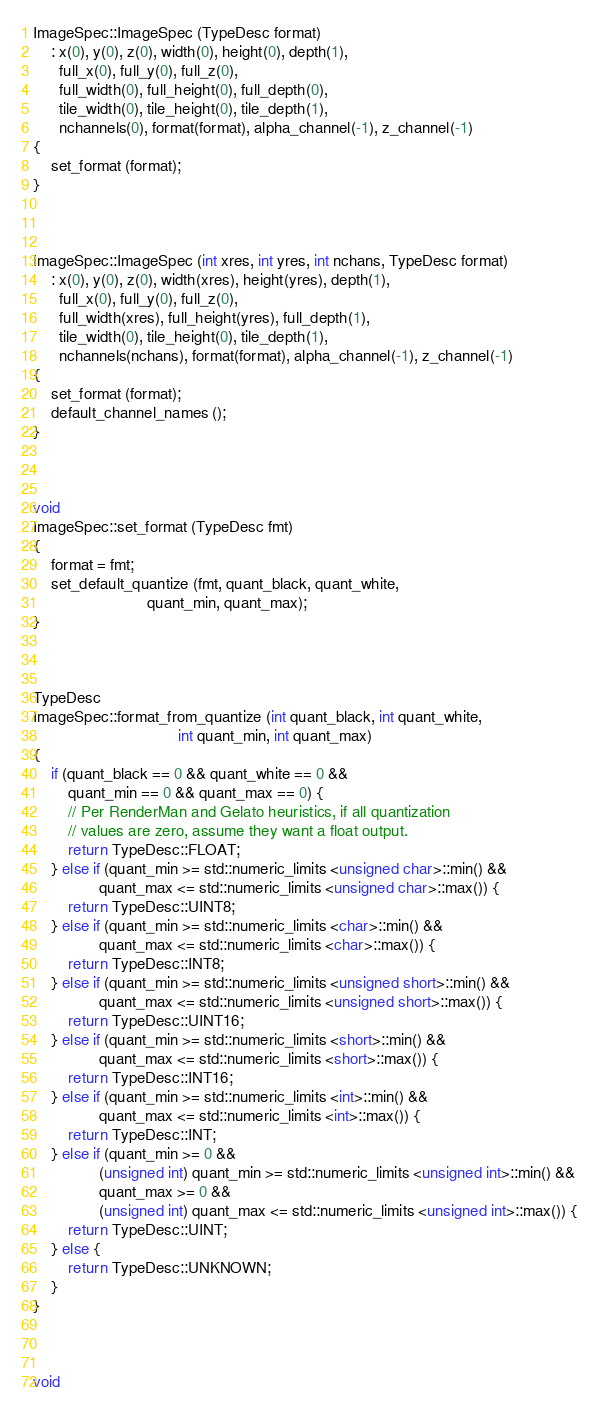<code> <loc_0><loc_0><loc_500><loc_500><_C++_>


ImageSpec::ImageSpec (TypeDesc format)
    : x(0), y(0), z(0), width(0), height(0), depth(1),
      full_x(0), full_y(0), full_z(0),
      full_width(0), full_height(0), full_depth(0),
      tile_width(0), tile_height(0), tile_depth(1),
      nchannels(0), format(format), alpha_channel(-1), z_channel(-1)
{
    set_format (format);
}



ImageSpec::ImageSpec (int xres, int yres, int nchans, TypeDesc format)
    : x(0), y(0), z(0), width(xres), height(yres), depth(1),
      full_x(0), full_y(0), full_z(0),
      full_width(xres), full_height(yres), full_depth(1),
      tile_width(0), tile_height(0), tile_depth(1),
      nchannels(nchans), format(format), alpha_channel(-1), z_channel(-1)
{
    set_format (format);
    default_channel_names ();
}



void
ImageSpec::set_format (TypeDesc fmt)
{
    format = fmt;
    set_default_quantize (fmt, quant_black, quant_white,
                          quant_min, quant_max);
}



TypeDesc
ImageSpec::format_from_quantize (int quant_black, int quant_white,
                                 int quant_min, int quant_max)
{
    if (quant_black == 0 && quant_white == 0 && 
        quant_min == 0 && quant_max == 0) {
        // Per RenderMan and Gelato heuristics, if all quantization
        // values are zero, assume they want a float output.
        return TypeDesc::FLOAT;
    } else if (quant_min >= std::numeric_limits <unsigned char>::min() && 
               quant_max <= std::numeric_limits <unsigned char>::max()) {
        return TypeDesc::UINT8;
    } else if (quant_min >= std::numeric_limits <char>::min() && 
               quant_max <= std::numeric_limits <char>::max()) {
        return TypeDesc::INT8;
    } else if (quant_min >= std::numeric_limits <unsigned short>::min() && 
               quant_max <= std::numeric_limits <unsigned short>::max()) {
        return TypeDesc::UINT16;
    } else if (quant_min >= std::numeric_limits <short>::min() && 
               quant_max <= std::numeric_limits <short>::max()) {
        return TypeDesc::INT16;
    } else if (quant_min >= std::numeric_limits <int>::min() && 
               quant_max <= std::numeric_limits <int>::max()) {
        return TypeDesc::INT;
    } else if (quant_min >= 0 && 
               (unsigned int) quant_min >= std::numeric_limits <unsigned int>::min() && 
               quant_max >= 0 &&
               (unsigned int) quant_max <= std::numeric_limits <unsigned int>::max()) {
        return TypeDesc::UINT;
    } else {
        return TypeDesc::UNKNOWN;
    }
}



void</code> 